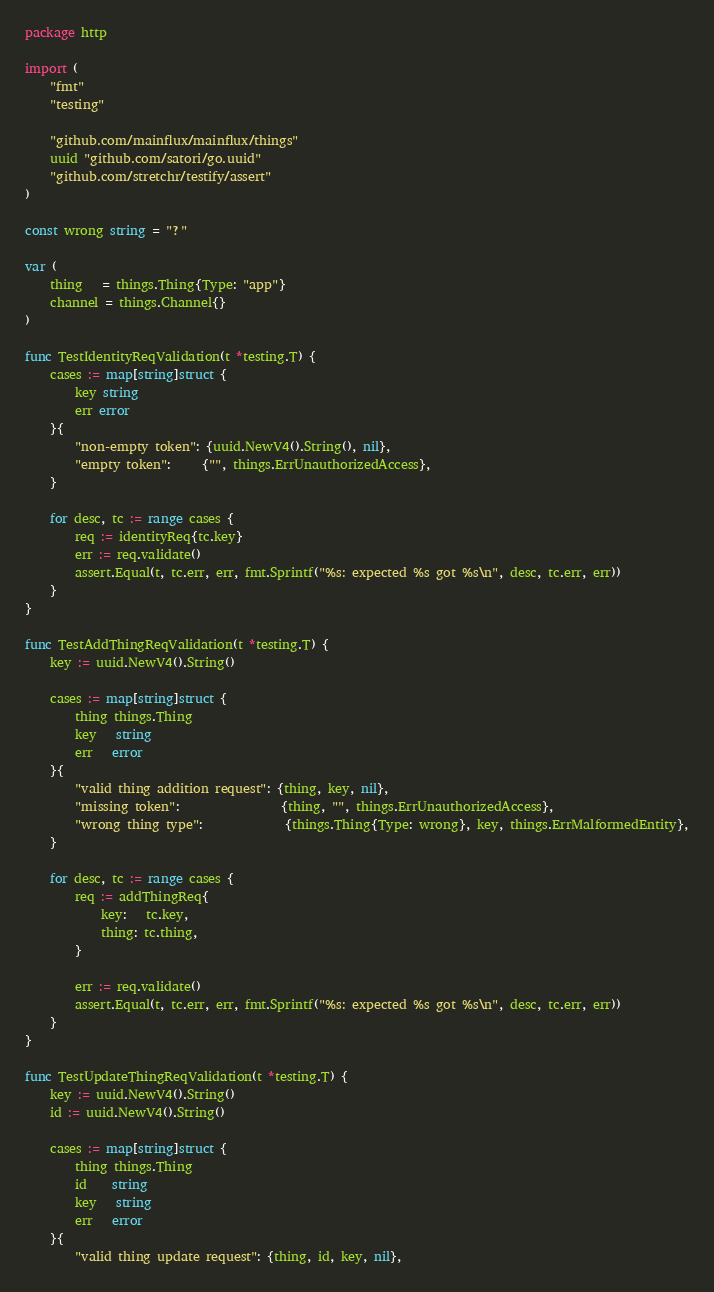<code> <loc_0><loc_0><loc_500><loc_500><_Go_>package http

import (
	"fmt"
	"testing"

	"github.com/mainflux/mainflux/things"
	uuid "github.com/satori/go.uuid"
	"github.com/stretchr/testify/assert"
)

const wrong string = "?"

var (
	thing   = things.Thing{Type: "app"}
	channel = things.Channel{}
)

func TestIdentityReqValidation(t *testing.T) {
	cases := map[string]struct {
		key string
		err error
	}{
		"non-empty token": {uuid.NewV4().String(), nil},
		"empty token":     {"", things.ErrUnauthorizedAccess},
	}

	for desc, tc := range cases {
		req := identityReq{tc.key}
		err := req.validate()
		assert.Equal(t, tc.err, err, fmt.Sprintf("%s: expected %s got %s\n", desc, tc.err, err))
	}
}

func TestAddThingReqValidation(t *testing.T) {
	key := uuid.NewV4().String()

	cases := map[string]struct {
		thing things.Thing
		key   string
		err   error
	}{
		"valid thing addition request": {thing, key, nil},
		"missing token":                {thing, "", things.ErrUnauthorizedAccess},
		"wrong thing type":             {things.Thing{Type: wrong}, key, things.ErrMalformedEntity},
	}

	for desc, tc := range cases {
		req := addThingReq{
			key:   tc.key,
			thing: tc.thing,
		}

		err := req.validate()
		assert.Equal(t, tc.err, err, fmt.Sprintf("%s: expected %s got %s\n", desc, tc.err, err))
	}
}

func TestUpdateThingReqValidation(t *testing.T) {
	key := uuid.NewV4().String()
	id := uuid.NewV4().String()

	cases := map[string]struct {
		thing things.Thing
		id    string
		key   string
		err   error
	}{
		"valid thing update request": {thing, id, key, nil},</code> 